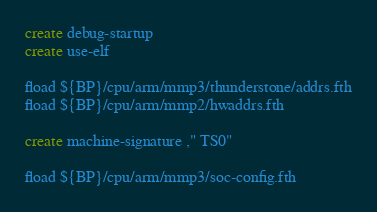Convert code to text. <code><loc_0><loc_0><loc_500><loc_500><_Forth_>create debug-startup
create use-elf

fload ${BP}/cpu/arm/mmp3/thunderstone/addrs.fth
fload ${BP}/cpu/arm/mmp2/hwaddrs.fth

create machine-signature ," TS0"

fload ${BP}/cpu/arm/mmp3/soc-config.fth
</code> 